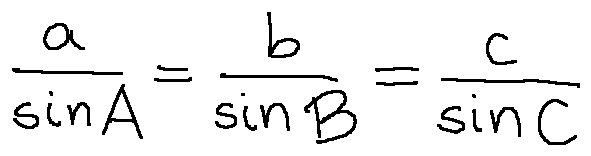<formula> <loc_0><loc_0><loc_500><loc_500>\frac { a } { \sin A } = \frac { b } { \sin B } = \frac { c } { \sin C }</formula> 